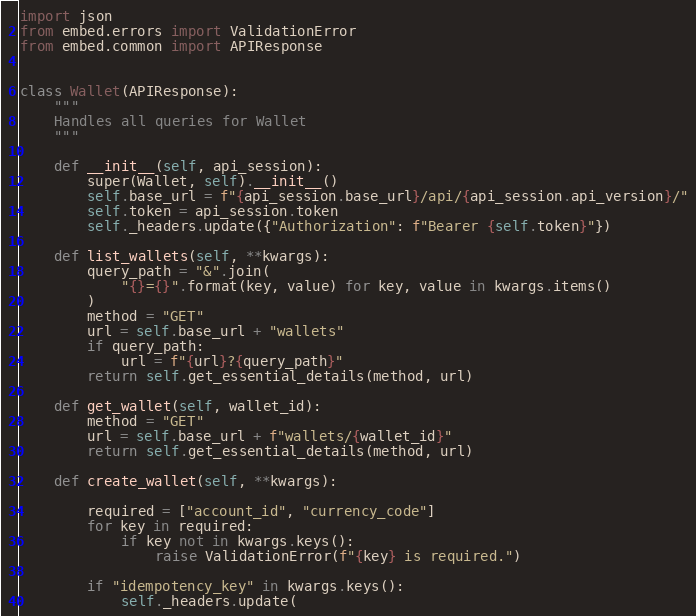<code> <loc_0><loc_0><loc_500><loc_500><_Python_>import json
from embed.errors import ValidationError
from embed.common import APIResponse


class Wallet(APIResponse):
    """
    Handles all queries for Wallet
    """

    def __init__(self, api_session):
        super(Wallet, self).__init__()
        self.base_url = f"{api_session.base_url}/api/{api_session.api_version}/"
        self.token = api_session.token
        self._headers.update({"Authorization": f"Bearer {self.token}"})

    def list_wallets(self, **kwargs):
        query_path = "&".join(
            "{}={}".format(key, value) for key, value in kwargs.items()
        )
        method = "GET"
        url = self.base_url + "wallets"
        if query_path:
            url = f"{url}?{query_path}"
        return self.get_essential_details(method, url)

    def get_wallet(self, wallet_id):
        method = "GET"
        url = self.base_url + f"wallets/{wallet_id}"
        return self.get_essential_details(method, url)

    def create_wallet(self, **kwargs):

        required = ["account_id", "currency_code"]
        for key in required:
            if key not in kwargs.keys():
                raise ValidationError(f"{key} is required.")

        if "idempotency_key" in kwargs.keys():
            self._headers.update(</code> 